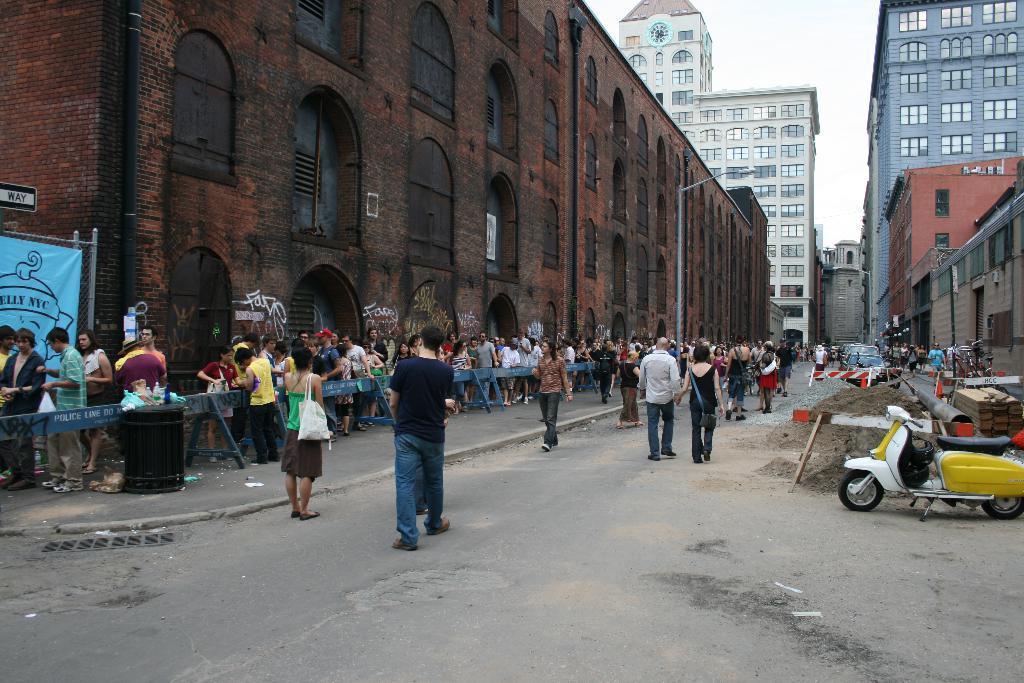Can you describe this image briefly? This is a street view image, there are few people walking down the street, on the either side of the street there are buildings. In front of one of the buildings there are people standing in a queue. There are a scooter and cars parked on the road, there is a lamp post in front of the building. 